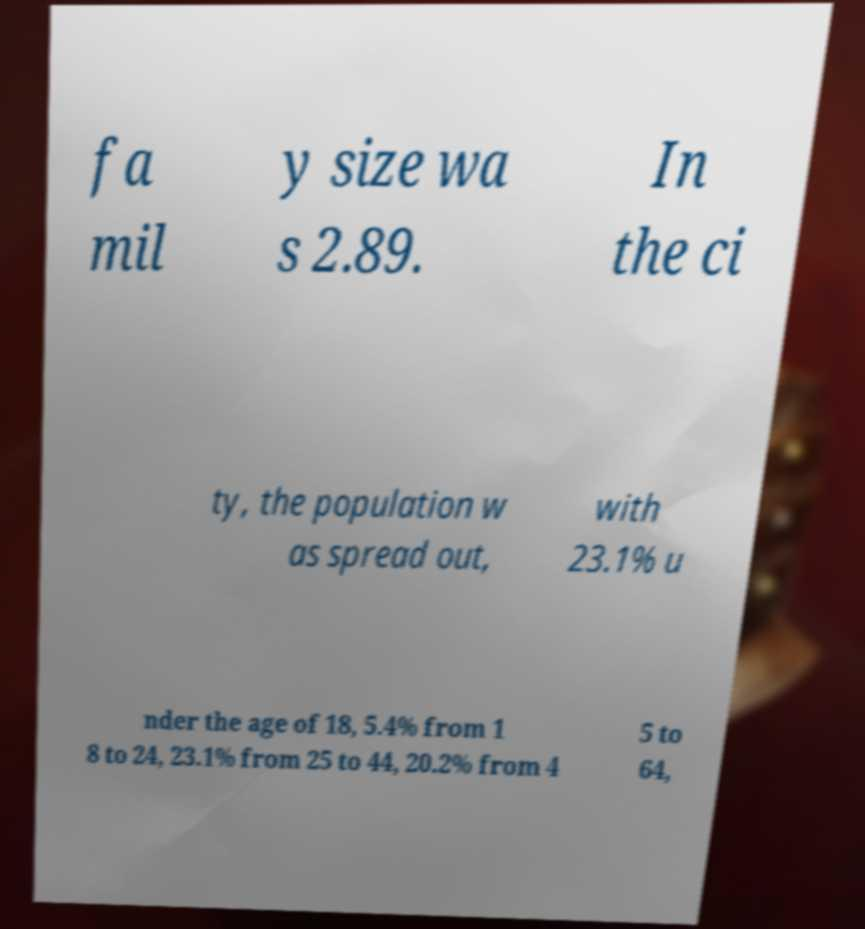What messages or text are displayed in this image? I need them in a readable, typed format. fa mil y size wa s 2.89. In the ci ty, the population w as spread out, with 23.1% u nder the age of 18, 5.4% from 1 8 to 24, 23.1% from 25 to 44, 20.2% from 4 5 to 64, 